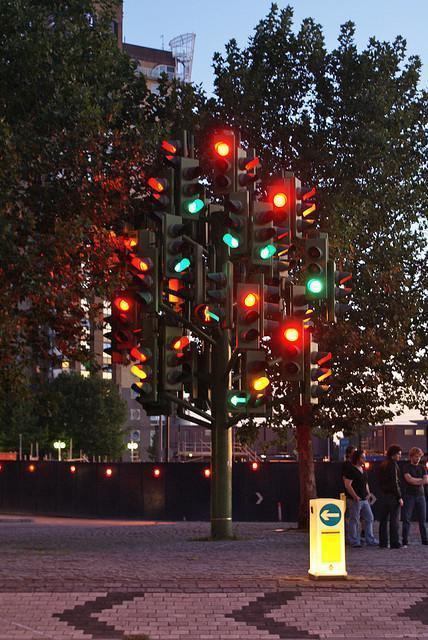How many pedestrians are here?
Give a very brief answer. 4. How many traffic lights can you see?
Give a very brief answer. 2. How many cats have a banana in their paws?
Give a very brief answer. 0. 